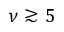Convert formula to latex. <formula><loc_0><loc_0><loc_500><loc_500>\nu \gtrsim 5</formula> 